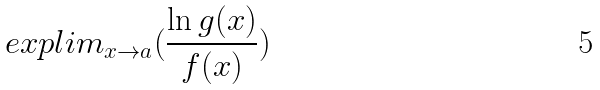<formula> <loc_0><loc_0><loc_500><loc_500>e x p l i m _ { x \rightarrow a } ( \frac { \ln g ( x ) } { f ( x ) } )</formula> 